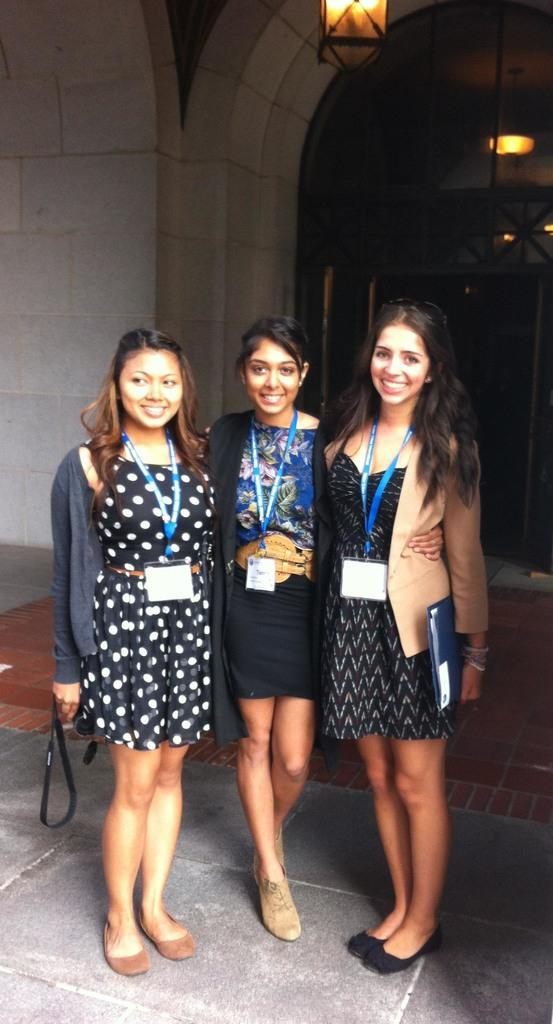How many people are in the image? There is a group of persons in the image. What are the persons in the image doing? The persons are standing and smiling. What can be seen on the persons in the image? The persons are wearing ID cards. What is visible in the image besides the persons? There are lights and a wall in the image. What type of engine can be seen in the image? There is no engine present in the image. What time of day is it in the image? The time of day cannot be determined from the image, as there is no information about lighting or shadows to suggest whether it is day or night. 